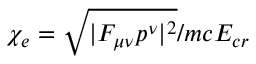<formula> <loc_0><loc_0><loc_500><loc_500>\chi _ { e } = \sqrt { | F _ { \mu \nu } p ^ { \nu } | ^ { 2 } } / m c E _ { c r }</formula> 